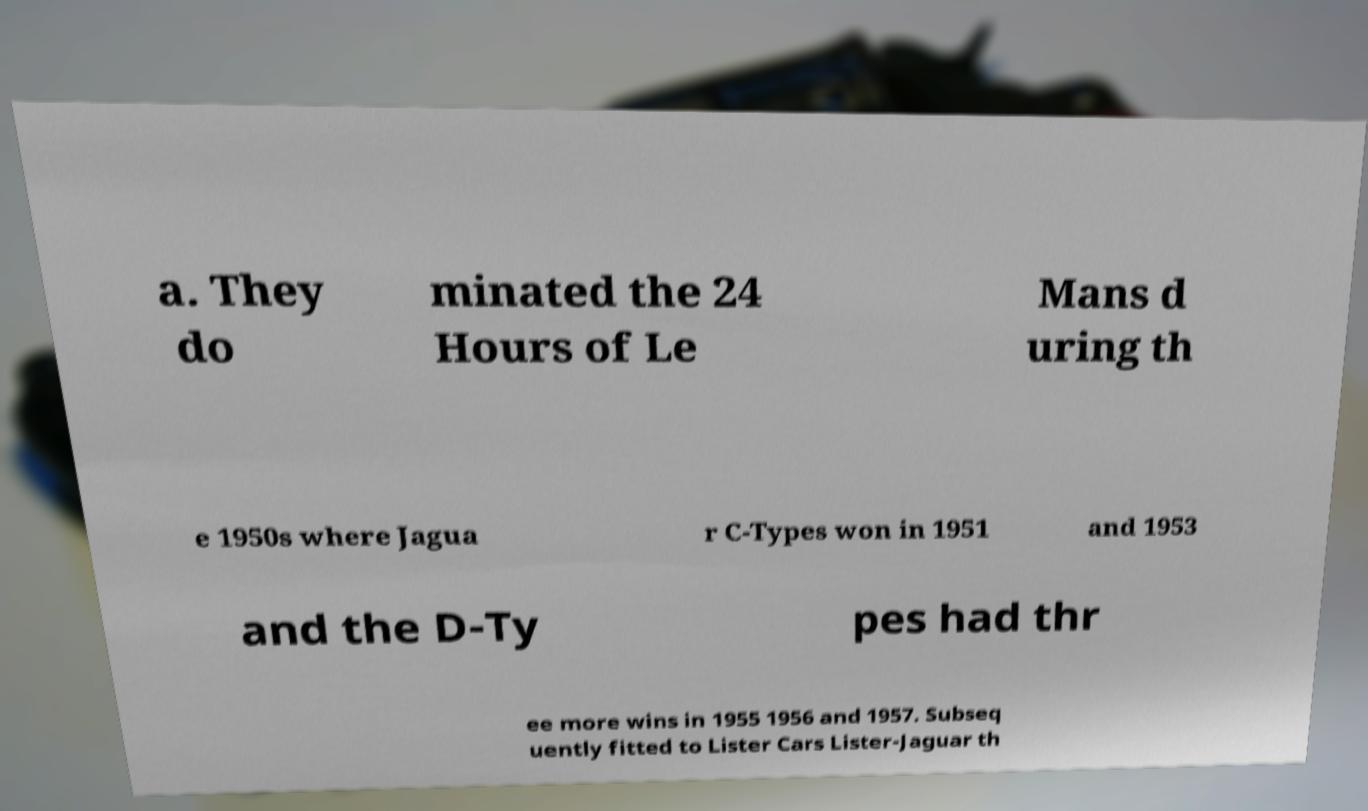I need the written content from this picture converted into text. Can you do that? a. They do minated the 24 Hours of Le Mans d uring th e 1950s where Jagua r C-Types won in 1951 and 1953 and the D-Ty pes had thr ee more wins in 1955 1956 and 1957. Subseq uently fitted to Lister Cars Lister-Jaguar th 